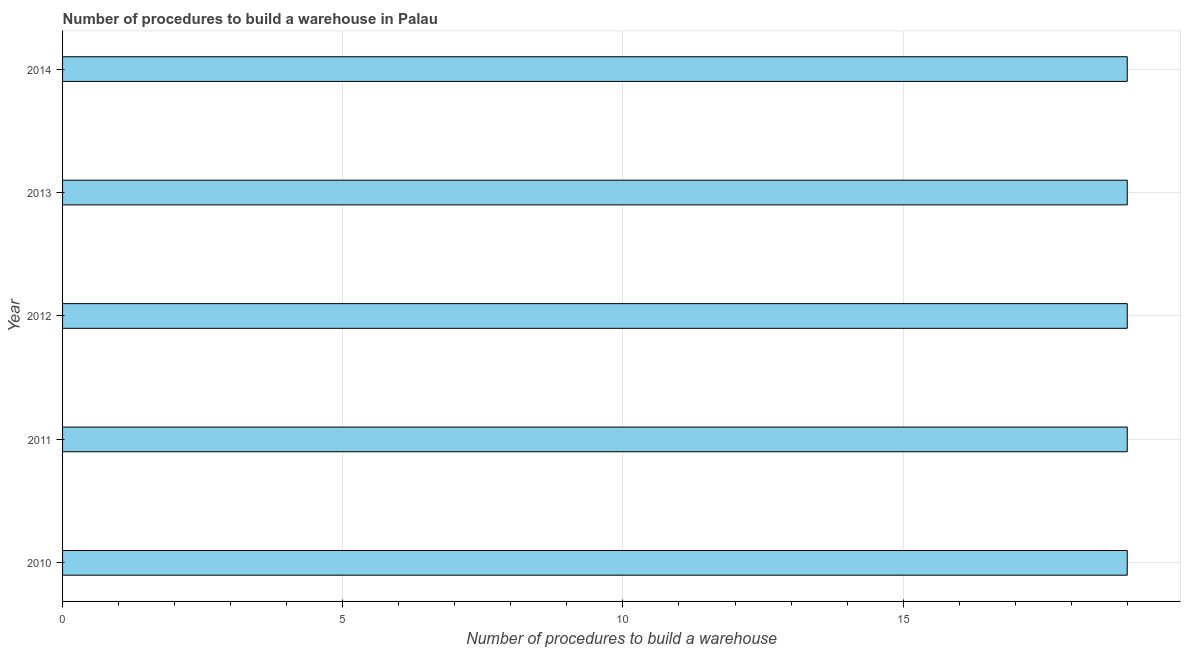Does the graph contain grids?
Offer a very short reply. Yes. What is the title of the graph?
Offer a very short reply. Number of procedures to build a warehouse in Palau. What is the label or title of the X-axis?
Give a very brief answer. Number of procedures to build a warehouse. What is the number of procedures to build a warehouse in 2011?
Keep it short and to the point. 19. Across all years, what is the minimum number of procedures to build a warehouse?
Provide a succinct answer. 19. In which year was the number of procedures to build a warehouse maximum?
Ensure brevity in your answer.  2010. What is the median number of procedures to build a warehouse?
Ensure brevity in your answer.  19. In how many years, is the number of procedures to build a warehouse greater than 15 ?
Offer a terse response. 5. Do a majority of the years between 2014 and 2013 (inclusive) have number of procedures to build a warehouse greater than 1 ?
Give a very brief answer. No. What is the difference between the highest and the second highest number of procedures to build a warehouse?
Provide a succinct answer. 0. Is the sum of the number of procedures to build a warehouse in 2010 and 2011 greater than the maximum number of procedures to build a warehouse across all years?
Make the answer very short. Yes. What is the difference between the highest and the lowest number of procedures to build a warehouse?
Keep it short and to the point. 0. In how many years, is the number of procedures to build a warehouse greater than the average number of procedures to build a warehouse taken over all years?
Make the answer very short. 0. How many bars are there?
Give a very brief answer. 5. Are all the bars in the graph horizontal?
Keep it short and to the point. Yes. What is the difference between two consecutive major ticks on the X-axis?
Ensure brevity in your answer.  5. What is the Number of procedures to build a warehouse of 2013?
Your response must be concise. 19. What is the difference between the Number of procedures to build a warehouse in 2010 and 2011?
Make the answer very short. 0. What is the difference between the Number of procedures to build a warehouse in 2010 and 2012?
Offer a terse response. 0. What is the difference between the Number of procedures to build a warehouse in 2010 and 2013?
Your answer should be very brief. 0. What is the difference between the Number of procedures to build a warehouse in 2011 and 2013?
Your answer should be very brief. 0. What is the difference between the Number of procedures to build a warehouse in 2012 and 2014?
Your answer should be very brief. 0. What is the difference between the Number of procedures to build a warehouse in 2013 and 2014?
Offer a terse response. 0. What is the ratio of the Number of procedures to build a warehouse in 2010 to that in 2013?
Keep it short and to the point. 1. What is the ratio of the Number of procedures to build a warehouse in 2010 to that in 2014?
Your response must be concise. 1. What is the ratio of the Number of procedures to build a warehouse in 2011 to that in 2012?
Your answer should be compact. 1. What is the ratio of the Number of procedures to build a warehouse in 2011 to that in 2013?
Give a very brief answer. 1. What is the ratio of the Number of procedures to build a warehouse in 2011 to that in 2014?
Ensure brevity in your answer.  1. What is the ratio of the Number of procedures to build a warehouse in 2012 to that in 2013?
Ensure brevity in your answer.  1. What is the ratio of the Number of procedures to build a warehouse in 2013 to that in 2014?
Offer a terse response. 1. 